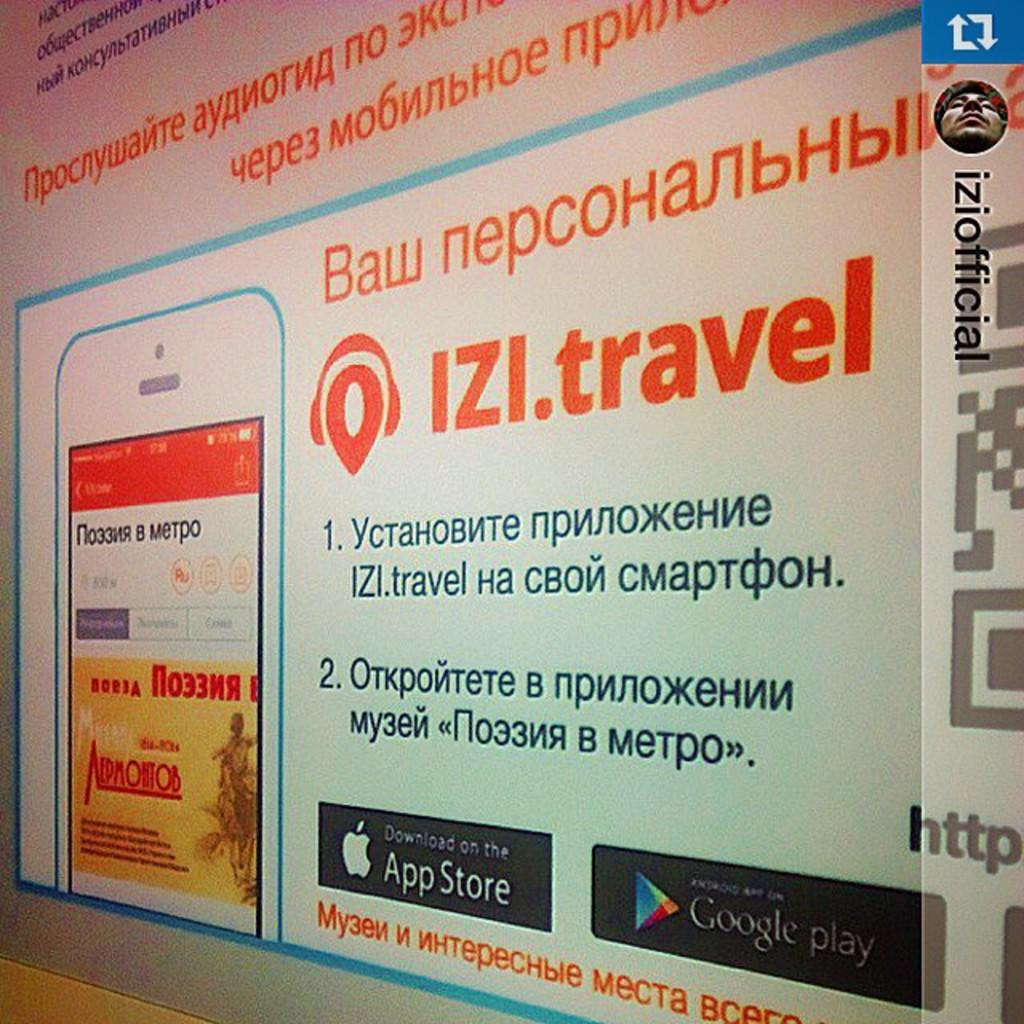Provide a one-sentence caption for the provided image. A large advertisment on a wall for IZI.travel. 